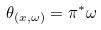Convert formula to latex. <formula><loc_0><loc_0><loc_500><loc_500>\theta _ { ( x , \omega ) } = \pi ^ { * } \omega</formula> 